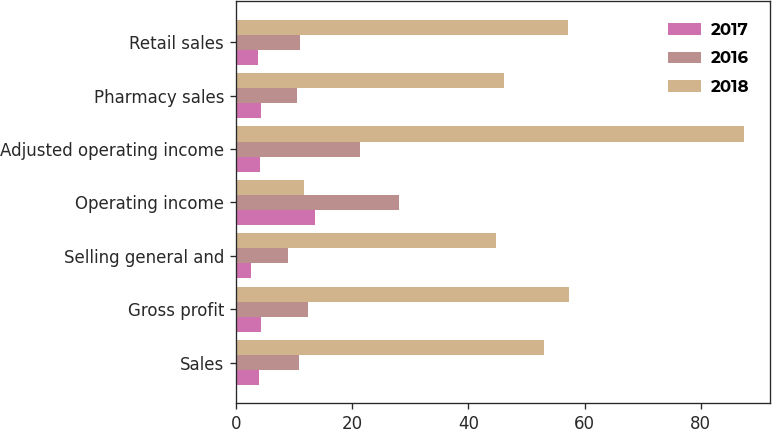Convert chart. <chart><loc_0><loc_0><loc_500><loc_500><stacked_bar_chart><ecel><fcel>Sales<fcel>Gross profit<fcel>Selling general and<fcel>Operating income<fcel>Adjusted operating income<fcel>Pharmacy sales<fcel>Retail sales<nl><fcel>2017<fcel>4<fcel>4.3<fcel>2.6<fcel>13.6<fcel>4.2<fcel>4.3<fcel>3.8<nl><fcel>2016<fcel>10.9<fcel>12.5<fcel>8.9<fcel>28<fcel>21.3<fcel>10.5<fcel>11.1<nl><fcel>2018<fcel>53.1<fcel>57.4<fcel>44.7<fcel>11.8<fcel>87.5<fcel>46.2<fcel>57.1<nl></chart> 